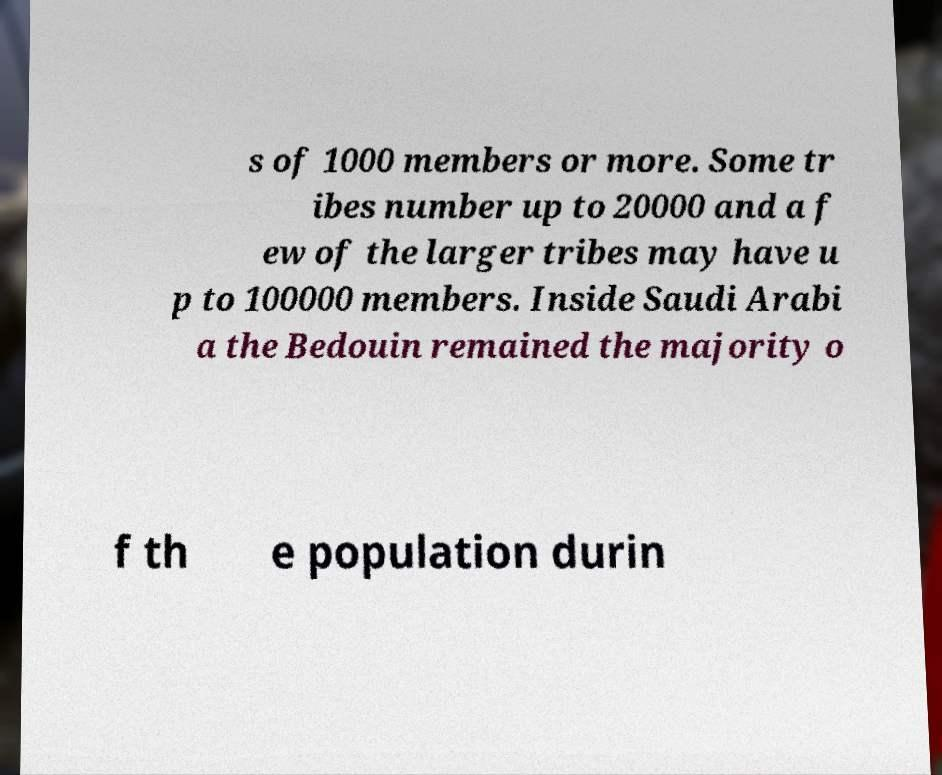I need the written content from this picture converted into text. Can you do that? s of 1000 members or more. Some tr ibes number up to 20000 and a f ew of the larger tribes may have u p to 100000 members. Inside Saudi Arabi a the Bedouin remained the majority o f th e population durin 